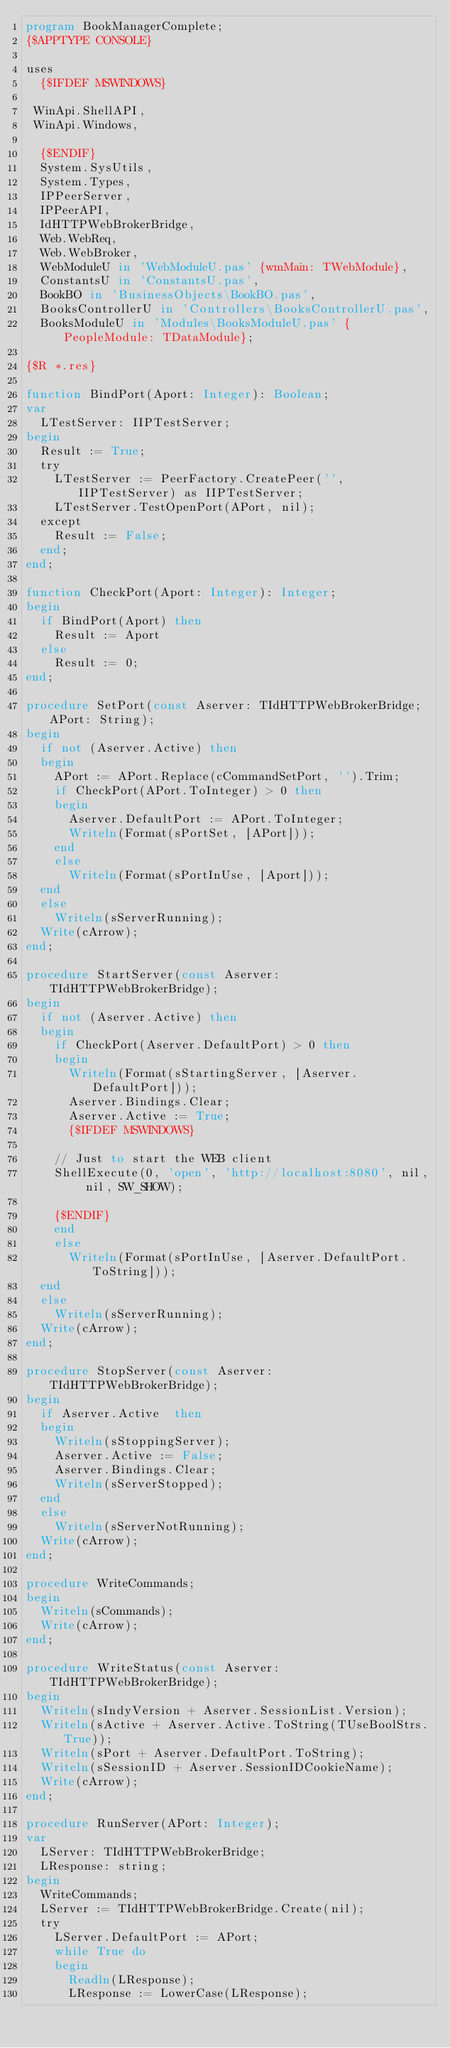Convert code to text. <code><loc_0><loc_0><loc_500><loc_500><_Pascal_>program BookManagerComplete;
{$APPTYPE CONSOLE}

uses
  {$IFDEF MSWINDOWS}

 WinApi.ShellAPI,
 WinApi.Windows,

  {$ENDIF}
  System.SysUtils,
  System.Types,
  IPPeerServer,
  IPPeerAPI,
  IdHTTPWebBrokerBridge,
  Web.WebReq,
  Web.WebBroker,
  WebModuleU in 'WebModuleU.pas' {wmMain: TWebModule},
  ConstantsU in 'ConstantsU.pas',
  BookBO in 'BusinessObjects\BookBO.pas',
  BooksControllerU in 'Controllers\BooksControllerU.pas',
  BooksModuleU in 'Modules\BooksModuleU.pas' {PeopleModule: TDataModule};

{$R *.res}

function BindPort(Aport: Integer): Boolean;
var
  LTestServer: IIPTestServer;
begin
  Result := True;
  try
    LTestServer := PeerFactory.CreatePeer('', IIPTestServer) as IIPTestServer;
    LTestServer.TestOpenPort(APort, nil);
  except
    Result := False;
  end;
end;

function CheckPort(Aport: Integer): Integer;
begin
  if BindPort(Aport) then
    Result := Aport
  else
    Result := 0;
end;

procedure SetPort(const Aserver: TIdHTTPWebBrokerBridge; APort: String);
begin
  if not (Aserver.Active) then
  begin
    APort := APort.Replace(cCommandSetPort, '').Trim;
    if CheckPort(APort.ToInteger) > 0 then
    begin
      Aserver.DefaultPort := APort.ToInteger;
      Writeln(Format(sPortSet, [APort]));
    end
    else
      Writeln(Format(sPortInUse, [Aport]));
  end
  else
    Writeln(sServerRunning);
  Write(cArrow);
end;

procedure StartServer(const Aserver: TIdHTTPWebBrokerBridge);
begin
  if not (Aserver.Active) then
  begin
    if CheckPort(Aserver.DefaultPort) > 0 then
    begin
      Writeln(Format(sStartingServer, [Aserver.DefaultPort]));
      Aserver.Bindings.Clear;
      Aserver.Active := True;
      {$IFDEF MSWINDOWS}

    // Just to start the WEB client
    ShellExecute(0, 'open', 'http://localhost:8080', nil, nil, SW_SHOW);

    {$ENDIF}
    end
    else
      Writeln(Format(sPortInUse, [Aserver.DefaultPort.ToString]));
  end
  else
    Writeln(sServerRunning);
  Write(cArrow);
end;

procedure StopServer(const Aserver: TIdHTTPWebBrokerBridge);
begin
  if Aserver.Active  then
  begin
    Writeln(sStoppingServer);
    Aserver.Active := False;
    Aserver.Bindings.Clear;
    Writeln(sServerStopped);
  end
  else
    Writeln(sServerNotRunning);
  Write(cArrow);
end;

procedure WriteCommands;
begin
  Writeln(sCommands);
  Write(cArrow);
end;

procedure WriteStatus(const Aserver: TIdHTTPWebBrokerBridge);
begin
  Writeln(sIndyVersion + Aserver.SessionList.Version);
  Writeln(sActive + Aserver.Active.ToString(TUseBoolStrs.True));
  Writeln(sPort + Aserver.DefaultPort.ToString);
  Writeln(sSessionID + Aserver.SessionIDCookieName);
  Write(cArrow);
end;

procedure RunServer(APort: Integer);
var
  LServer: TIdHTTPWebBrokerBridge;
  LResponse: string;
begin
  WriteCommands;
  LServer := TIdHTTPWebBrokerBridge.Create(nil);
  try
    LServer.DefaultPort := APort;
    while True do
    begin
      Readln(LResponse);
      LResponse := LowerCase(LResponse);</code> 